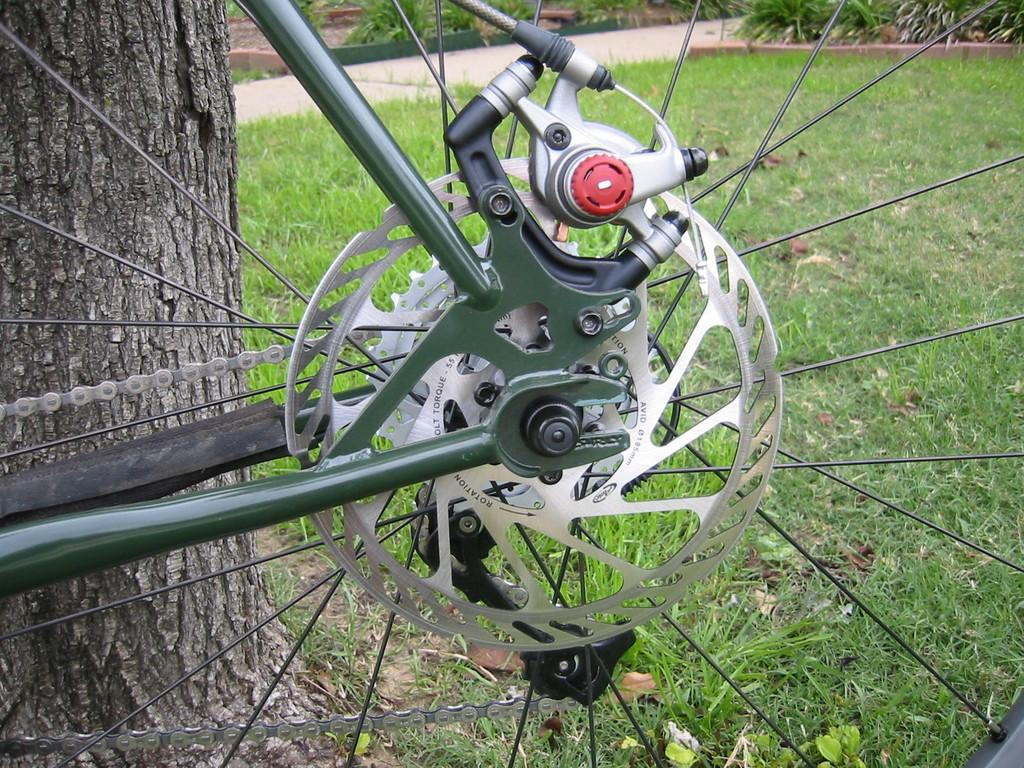What object is partially visible in the image? There is a truncated part of a wheel in the image. What type of terrain is visible in the image? There is grass visible in the image. What large object is present in the image? There is a trunk in the image. What can be seen in the background of the image? There are plants in the background of the image. What type of cork can be seen in the image? There is no cork present in the image. What position is the wheel in the image? The wheel is partially visible, with a truncated part shown in the image. 